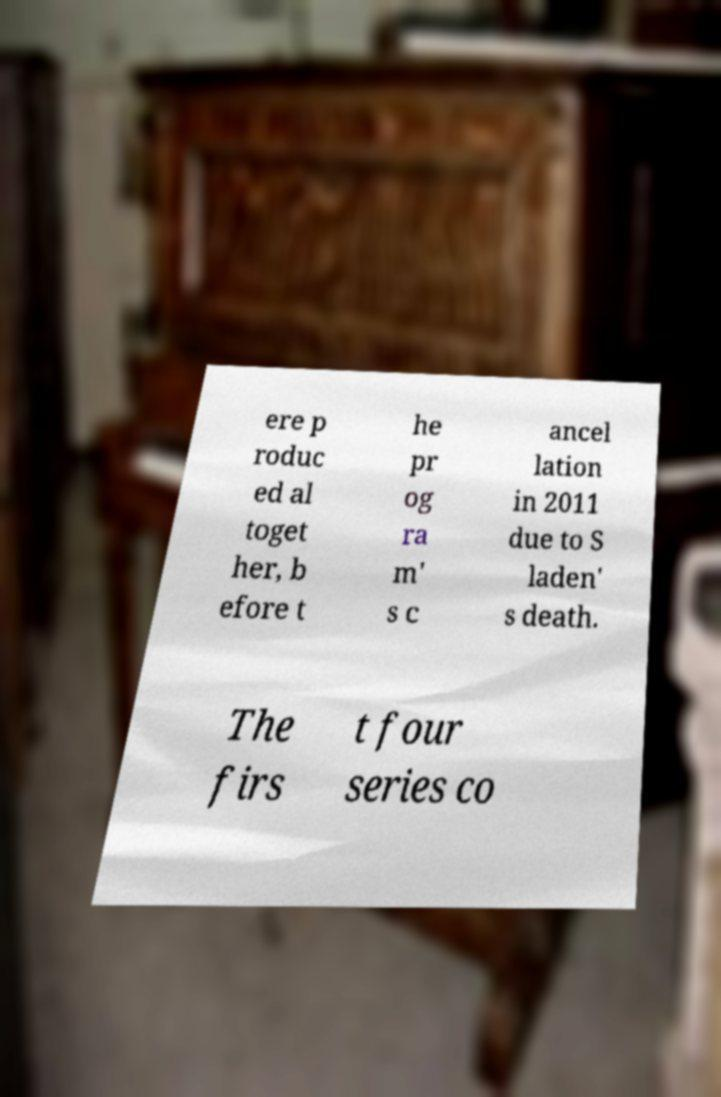Could you extract and type out the text from this image? ere p roduc ed al toget her, b efore t he pr og ra m' s c ancel lation in 2011 due to S laden' s death. The firs t four series co 